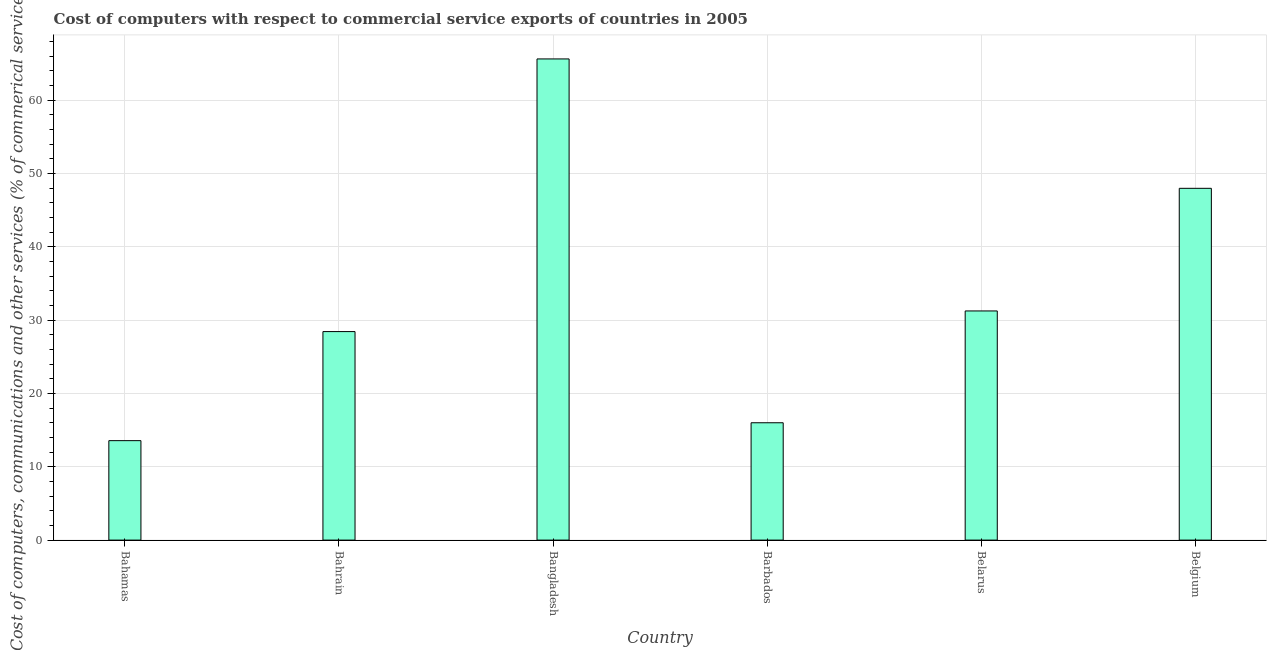Does the graph contain any zero values?
Your answer should be compact. No. What is the title of the graph?
Provide a short and direct response. Cost of computers with respect to commercial service exports of countries in 2005. What is the label or title of the Y-axis?
Ensure brevity in your answer.  Cost of computers, communications and other services (% of commerical service exports). What is the  computer and other services in Barbados?
Offer a very short reply. 16. Across all countries, what is the maximum cost of communications?
Your answer should be compact. 65.62. Across all countries, what is the minimum  computer and other services?
Your answer should be very brief. 13.56. In which country was the  computer and other services maximum?
Your response must be concise. Bangladesh. In which country was the  computer and other services minimum?
Offer a very short reply. Bahamas. What is the sum of the cost of communications?
Your response must be concise. 202.84. What is the difference between the  computer and other services in Belarus and Belgium?
Your answer should be very brief. -16.72. What is the average cost of communications per country?
Make the answer very short. 33.81. What is the median  computer and other services?
Offer a terse response. 29.84. What is the ratio of the  computer and other services in Bahamas to that in Barbados?
Your response must be concise. 0.85. Is the difference between the cost of communications in Bangladesh and Belarus greater than the difference between any two countries?
Provide a short and direct response. No. What is the difference between the highest and the second highest cost of communications?
Provide a succinct answer. 17.64. What is the difference between the highest and the lowest  computer and other services?
Make the answer very short. 52.06. In how many countries, is the  computer and other services greater than the average  computer and other services taken over all countries?
Give a very brief answer. 2. Are all the bars in the graph horizontal?
Your answer should be compact. No. How many countries are there in the graph?
Your answer should be compact. 6. Are the values on the major ticks of Y-axis written in scientific E-notation?
Provide a succinct answer. No. What is the Cost of computers, communications and other services (% of commerical service exports) in Bahamas?
Give a very brief answer. 13.56. What is the Cost of computers, communications and other services (% of commerical service exports) in Bahrain?
Provide a succinct answer. 28.43. What is the Cost of computers, communications and other services (% of commerical service exports) in Bangladesh?
Offer a terse response. 65.62. What is the Cost of computers, communications and other services (% of commerical service exports) in Barbados?
Keep it short and to the point. 16. What is the Cost of computers, communications and other services (% of commerical service exports) of Belarus?
Your answer should be very brief. 31.25. What is the Cost of computers, communications and other services (% of commerical service exports) of Belgium?
Your answer should be compact. 47.97. What is the difference between the Cost of computers, communications and other services (% of commerical service exports) in Bahamas and Bahrain?
Keep it short and to the point. -14.87. What is the difference between the Cost of computers, communications and other services (% of commerical service exports) in Bahamas and Bangladesh?
Ensure brevity in your answer.  -52.06. What is the difference between the Cost of computers, communications and other services (% of commerical service exports) in Bahamas and Barbados?
Provide a succinct answer. -2.44. What is the difference between the Cost of computers, communications and other services (% of commerical service exports) in Bahamas and Belarus?
Provide a succinct answer. -17.69. What is the difference between the Cost of computers, communications and other services (% of commerical service exports) in Bahamas and Belgium?
Your response must be concise. -34.41. What is the difference between the Cost of computers, communications and other services (% of commerical service exports) in Bahrain and Bangladesh?
Provide a short and direct response. -37.18. What is the difference between the Cost of computers, communications and other services (% of commerical service exports) in Bahrain and Barbados?
Ensure brevity in your answer.  12.43. What is the difference between the Cost of computers, communications and other services (% of commerical service exports) in Bahrain and Belarus?
Your response must be concise. -2.82. What is the difference between the Cost of computers, communications and other services (% of commerical service exports) in Bahrain and Belgium?
Ensure brevity in your answer.  -19.54. What is the difference between the Cost of computers, communications and other services (% of commerical service exports) in Bangladesh and Barbados?
Your response must be concise. 49.61. What is the difference between the Cost of computers, communications and other services (% of commerical service exports) in Bangladesh and Belarus?
Ensure brevity in your answer.  34.37. What is the difference between the Cost of computers, communications and other services (% of commerical service exports) in Bangladesh and Belgium?
Keep it short and to the point. 17.64. What is the difference between the Cost of computers, communications and other services (% of commerical service exports) in Barbados and Belarus?
Your answer should be compact. -15.25. What is the difference between the Cost of computers, communications and other services (% of commerical service exports) in Barbados and Belgium?
Give a very brief answer. -31.97. What is the difference between the Cost of computers, communications and other services (% of commerical service exports) in Belarus and Belgium?
Make the answer very short. -16.72. What is the ratio of the Cost of computers, communications and other services (% of commerical service exports) in Bahamas to that in Bahrain?
Provide a short and direct response. 0.48. What is the ratio of the Cost of computers, communications and other services (% of commerical service exports) in Bahamas to that in Bangladesh?
Ensure brevity in your answer.  0.21. What is the ratio of the Cost of computers, communications and other services (% of commerical service exports) in Bahamas to that in Barbados?
Keep it short and to the point. 0.85. What is the ratio of the Cost of computers, communications and other services (% of commerical service exports) in Bahamas to that in Belarus?
Give a very brief answer. 0.43. What is the ratio of the Cost of computers, communications and other services (% of commerical service exports) in Bahamas to that in Belgium?
Keep it short and to the point. 0.28. What is the ratio of the Cost of computers, communications and other services (% of commerical service exports) in Bahrain to that in Bangladesh?
Give a very brief answer. 0.43. What is the ratio of the Cost of computers, communications and other services (% of commerical service exports) in Bahrain to that in Barbados?
Provide a short and direct response. 1.78. What is the ratio of the Cost of computers, communications and other services (% of commerical service exports) in Bahrain to that in Belarus?
Offer a very short reply. 0.91. What is the ratio of the Cost of computers, communications and other services (% of commerical service exports) in Bahrain to that in Belgium?
Offer a terse response. 0.59. What is the ratio of the Cost of computers, communications and other services (% of commerical service exports) in Bangladesh to that in Barbados?
Offer a terse response. 4.1. What is the ratio of the Cost of computers, communications and other services (% of commerical service exports) in Bangladesh to that in Belgium?
Provide a succinct answer. 1.37. What is the ratio of the Cost of computers, communications and other services (% of commerical service exports) in Barbados to that in Belarus?
Keep it short and to the point. 0.51. What is the ratio of the Cost of computers, communications and other services (% of commerical service exports) in Barbados to that in Belgium?
Offer a terse response. 0.33. What is the ratio of the Cost of computers, communications and other services (% of commerical service exports) in Belarus to that in Belgium?
Provide a short and direct response. 0.65. 